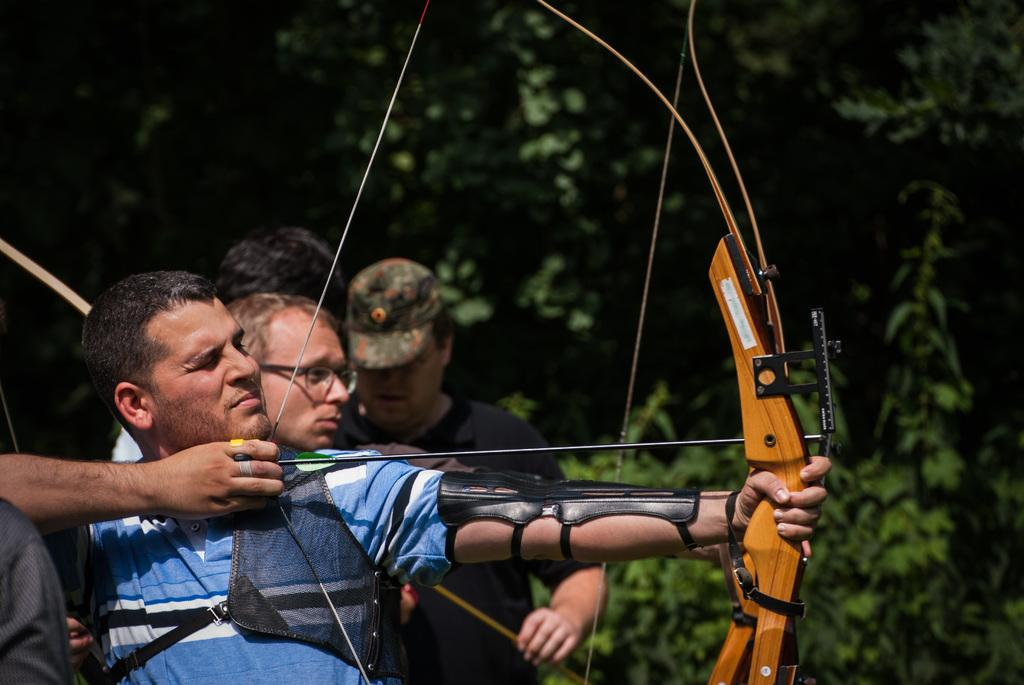How many people are in the image? There are people in the image, but the exact number cannot be determined due to the blurred quality. What activity is one person engaged in? One person is playing archery in the image. What type of natural environment is visible in the image? There are trees in the image, suggesting a natural setting. What type of plant is providing pleasure to the people in the image? There is no plant visible in the image, and no indication that any plant is providing pleasure to the people. 